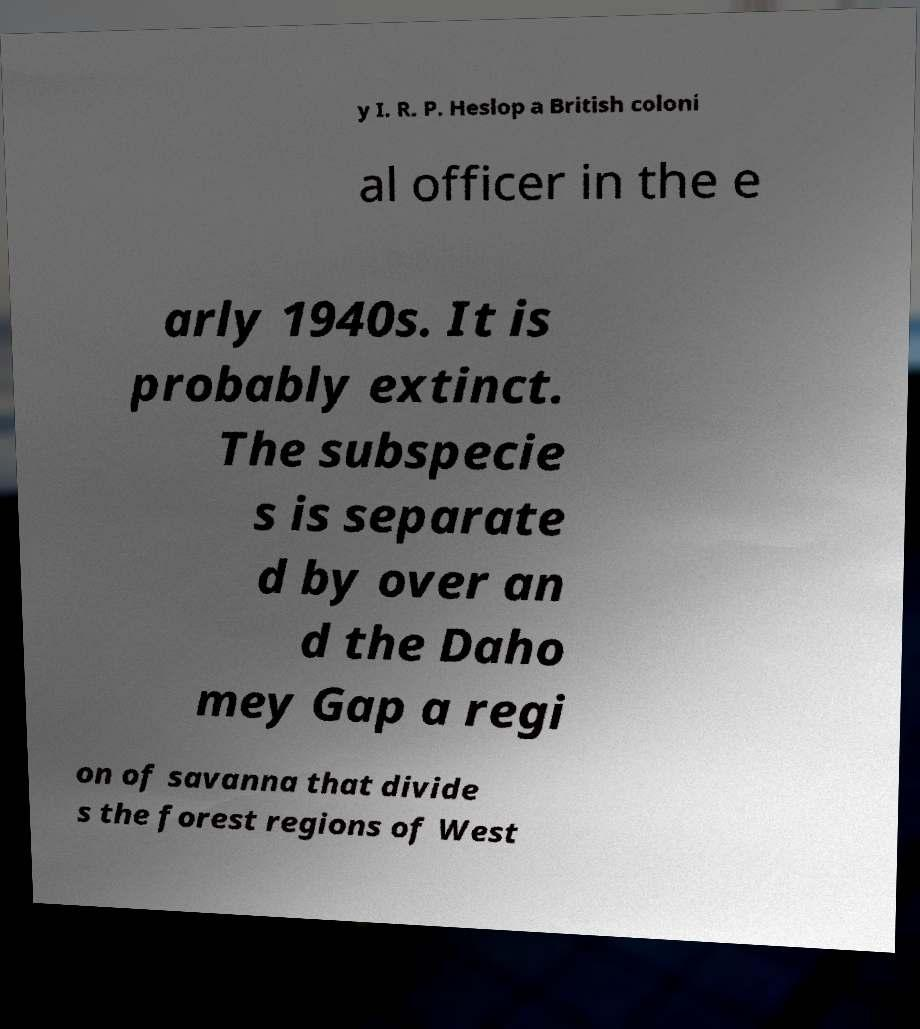Could you extract and type out the text from this image? y I. R. P. Heslop a British coloni al officer in the e arly 1940s. It is probably extinct. The subspecie s is separate d by over an d the Daho mey Gap a regi on of savanna that divide s the forest regions of West 